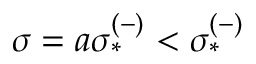<formula> <loc_0><loc_0><loc_500><loc_500>\sigma = a \sigma _ { * } ^ { ( - ) } < \sigma _ { * } ^ { ( - ) }</formula> 